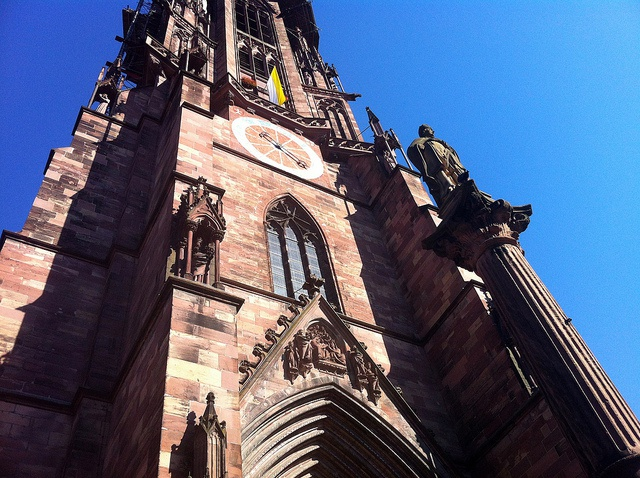Describe the objects in this image and their specific colors. I can see a clock in blue, white, tan, and darkgray tones in this image. 